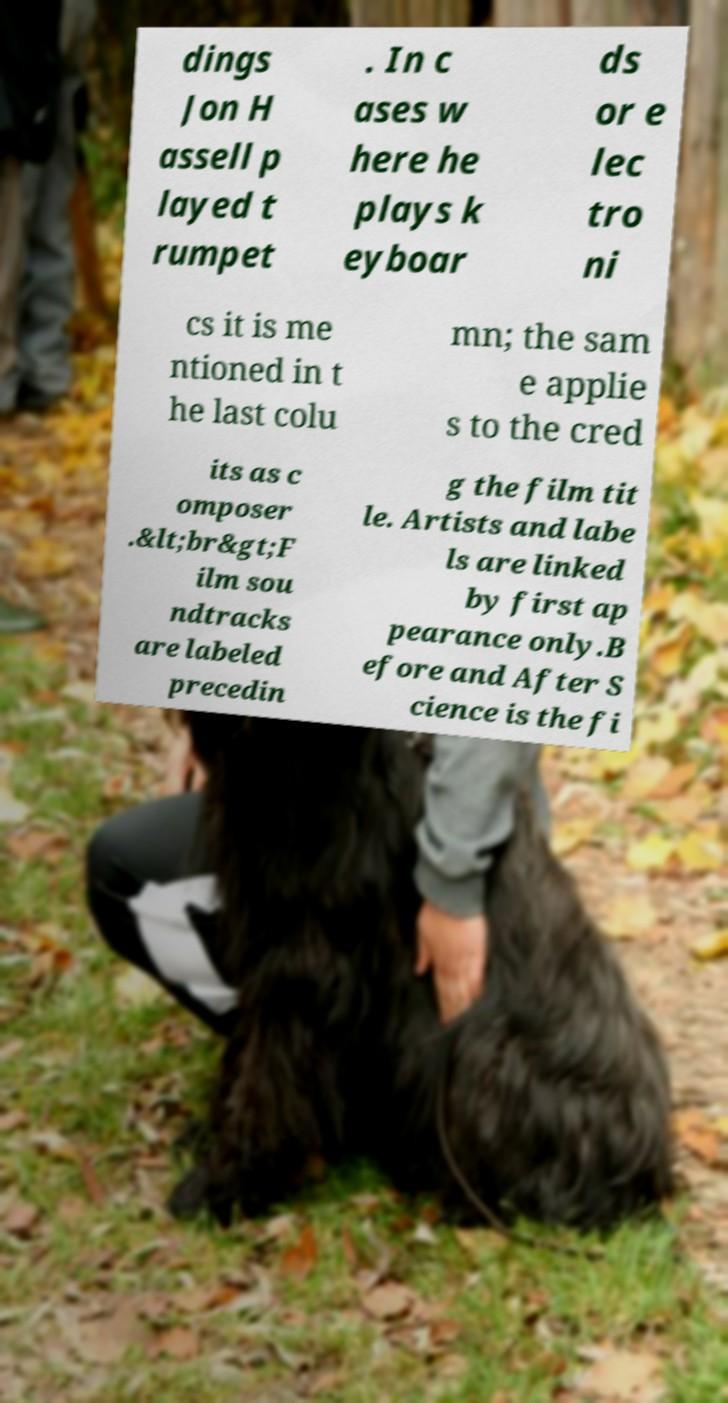Can you read and provide the text displayed in the image?This photo seems to have some interesting text. Can you extract and type it out for me? dings Jon H assell p layed t rumpet . In c ases w here he plays k eyboar ds or e lec tro ni cs it is me ntioned in t he last colu mn; the sam e applie s to the cred its as c omposer .&lt;br&gt;F ilm sou ndtracks are labeled precedin g the film tit le. Artists and labe ls are linked by first ap pearance only.B efore and After S cience is the fi 